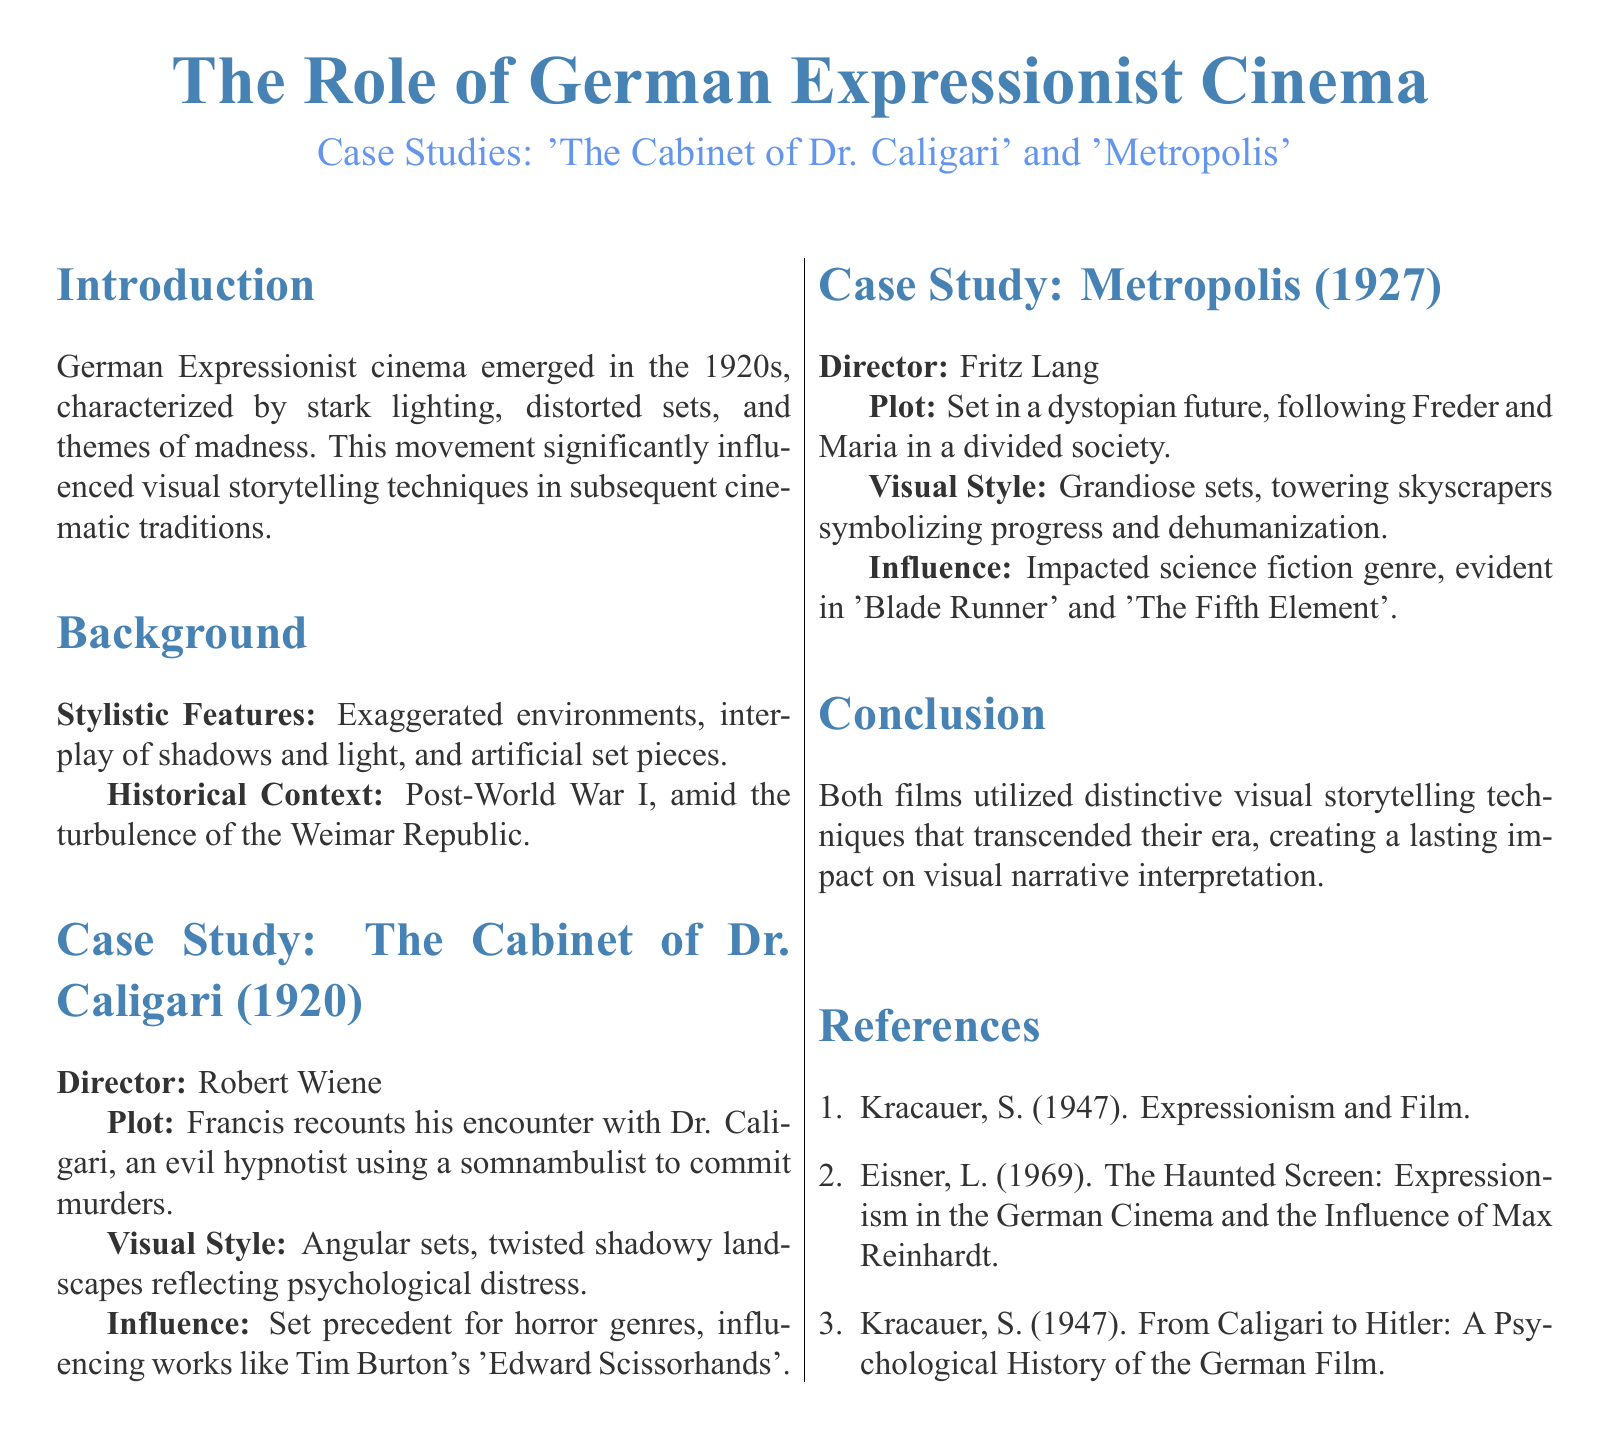What is the title of the case study? The title indicates the focus of the study and is found at the beginning of the document.
Answer: The Role of German Expressionist Cinema Who directed 'The Cabinet of Dr. Caligari'? The document specifies the director of the film in the case study section for the film.
Answer: Robert Wiene What year was 'Metropolis' released? The year of release is essential information found alongside the film in the case study section.
Answer: 1927 What technique is noted as influencing the horror genre? The document mentions the influence of a specific visual storytelling technique relating to horror films.
Answer: Set precedent for horror genres What themes are associated with German Expressionist cinema? Themes are discussed in the introduction and reflect the movement's core aspects.
Answer: Madness What type of sets characterize 'Metropolis'? The document describes the visual style of the film, focusing on the type of sets used.
Answer: Grandiose sets What is a prominent influence of 'Metropolis' mentioned? The influence of 'Metropolis' on future films is noted, indicating its significance across genres.
Answer: Science fiction genre How does 'The Cabinet of Dr. Caligari' reflect psychological distress? The document states the visual style of the film, which showcases its thematic concerns.
Answer: Twisted shadowy landscapes 